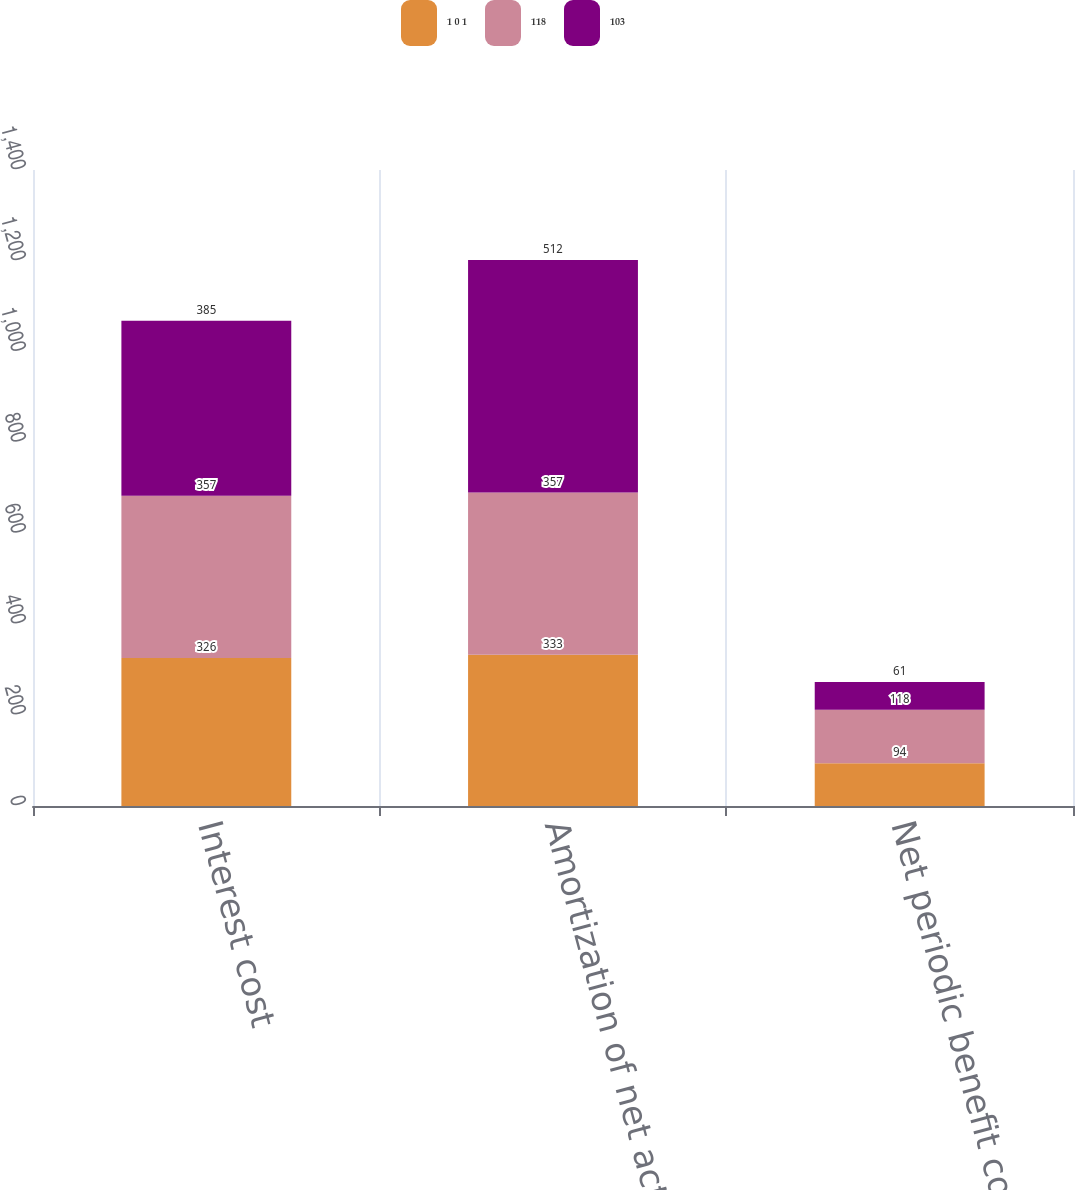Convert chart to OTSL. <chart><loc_0><loc_0><loc_500><loc_500><stacked_bar_chart><ecel><fcel>Interest cost<fcel>Amortization of net actuarial<fcel>Net periodic benefit cost<nl><fcel>1 0 1<fcel>326<fcel>333<fcel>94<nl><fcel>118<fcel>357<fcel>357<fcel>118<nl><fcel>103<fcel>385<fcel>512<fcel>61<nl></chart> 